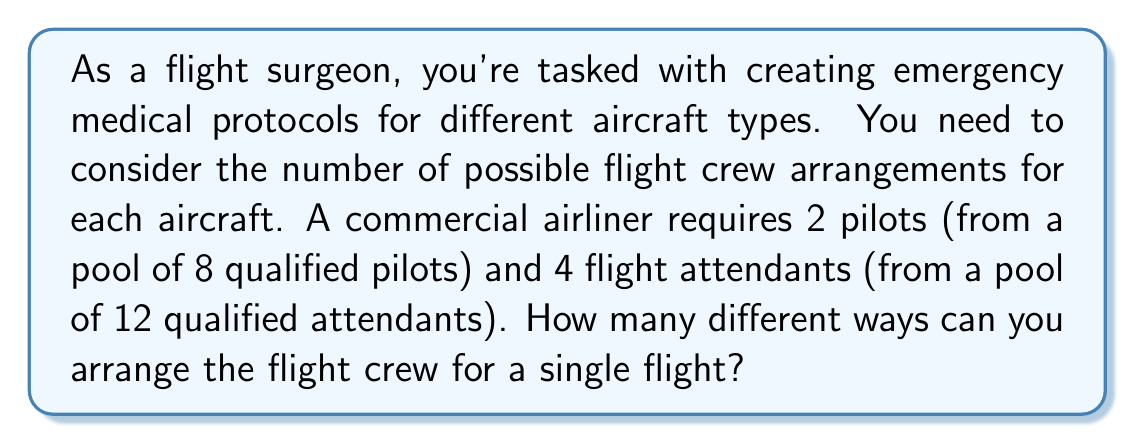Provide a solution to this math problem. To solve this problem, we need to use the multiplication principle of counting and combinations. Let's break it down step-by-step:

1. Selecting pilots:
   We need to choose 2 pilots from a pool of 8. This is a combination problem, as the order doesn't matter (both pilots are equally important). We use the combination formula:

   $$C(8,2) = \frac{8!}{2!(8-2)!} = \frac{8!}{2!6!} = 28$$

2. Selecting flight attendants:
   We need to choose 4 flight attendants from a pool of 12. Again, this is a combination:

   $$C(12,4) = \frac{12!}{4!(12-4)!} = \frac{12!}{4!8!} = 495$$

3. Applying the multiplication principle:
   Since we need to select both pilots AND flight attendants for each arrangement, we multiply the number of ways to select pilots by the number of ways to select flight attendants:

   $$28 \times 495 = 13,860$$

Therefore, the total number of possible flight crew arrangements is 13,860.
Answer: 13,860 possible flight crew arrangements 